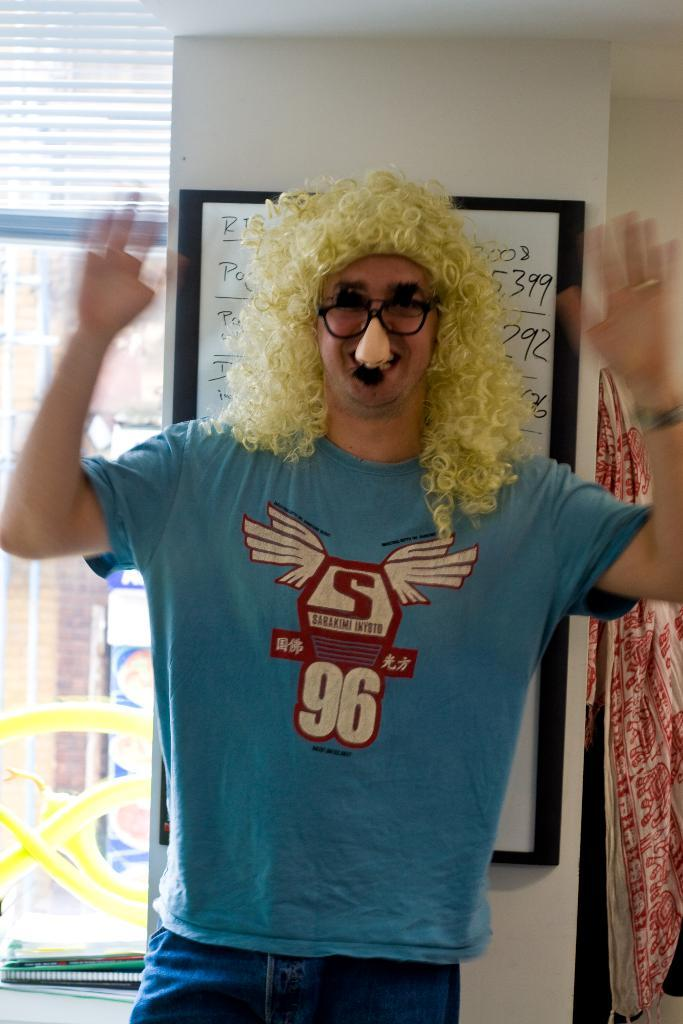What is the main subject of the image? There is a person standing in the image. What accessories is the person wearing? The person is wearing an artificial nose, spectacles, and a curly hair wig. What is the person's credit score in the image? There is no information about the person's credit score in the image. Who does the person have a crush on in the image? There is no information about the person having a crush on anyone in the image. 